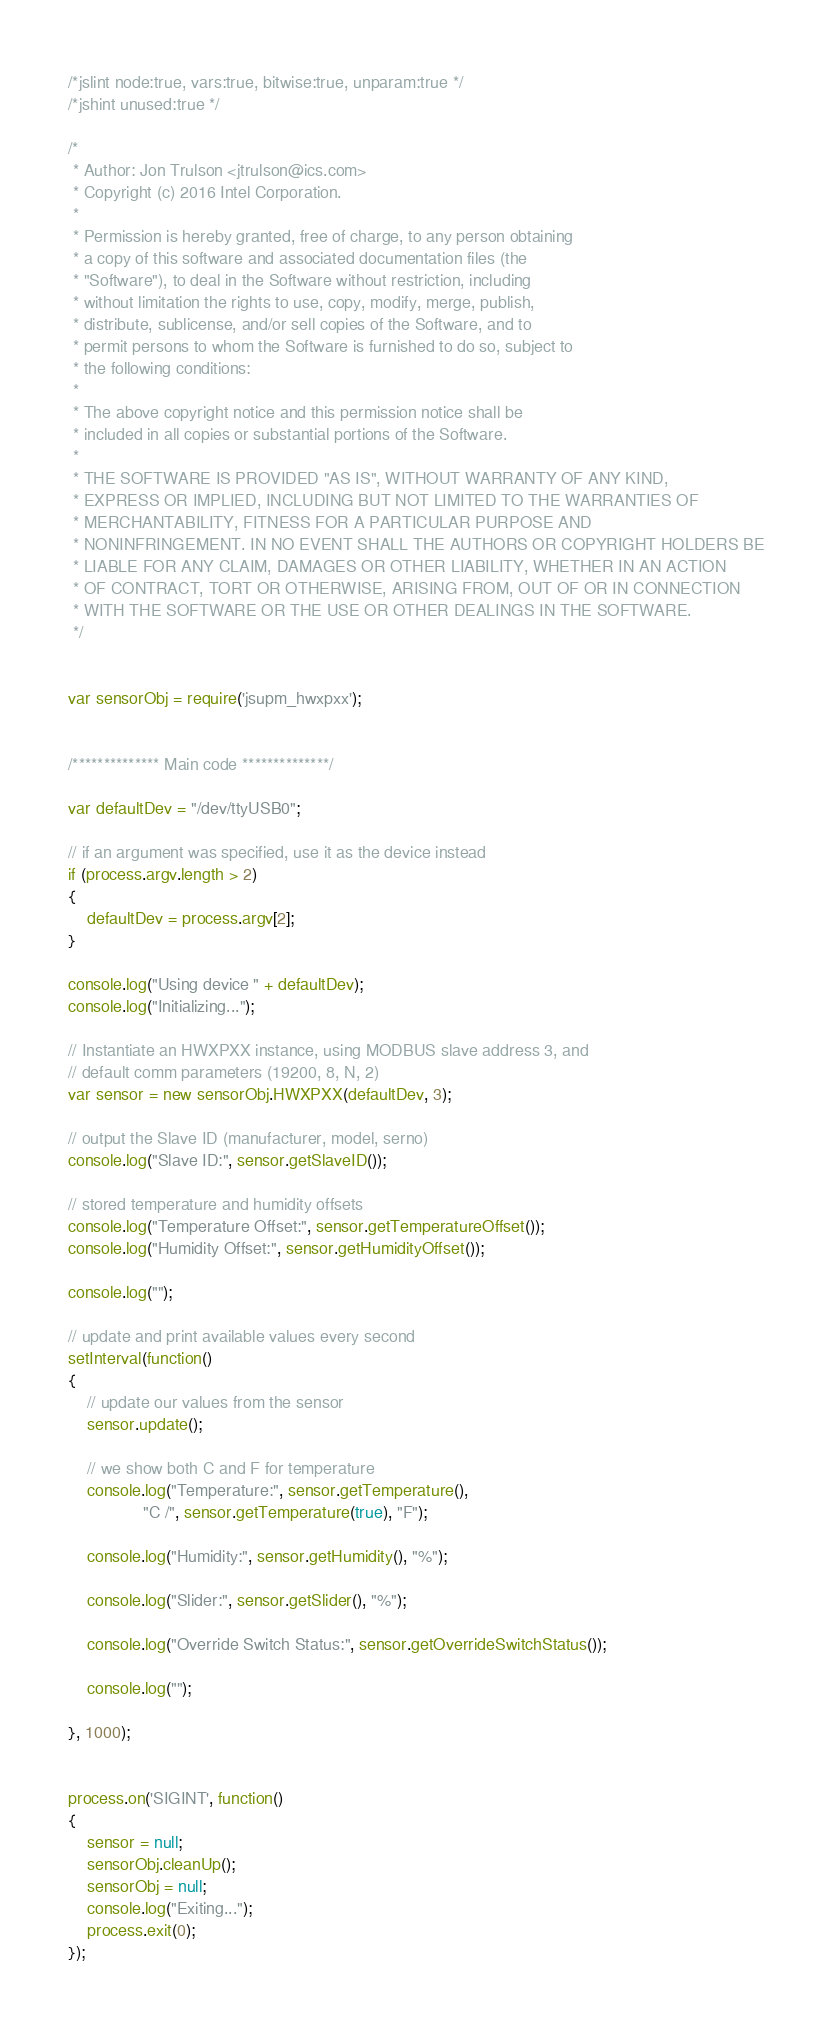<code> <loc_0><loc_0><loc_500><loc_500><_JavaScript_>/*jslint node:true, vars:true, bitwise:true, unparam:true */
/*jshint unused:true */

/*
 * Author: Jon Trulson <jtrulson@ics.com>
 * Copyright (c) 2016 Intel Corporation.
 *
 * Permission is hereby granted, free of charge, to any person obtaining
 * a copy of this software and associated documentation files (the
 * "Software"), to deal in the Software without restriction, including
 * without limitation the rights to use, copy, modify, merge, publish,
 * distribute, sublicense, and/or sell copies of the Software, and to
 * permit persons to whom the Software is furnished to do so, subject to
 * the following conditions:
 *
 * The above copyright notice and this permission notice shall be
 * included in all copies or substantial portions of the Software.
 *
 * THE SOFTWARE IS PROVIDED "AS IS", WITHOUT WARRANTY OF ANY KIND,
 * EXPRESS OR IMPLIED, INCLUDING BUT NOT LIMITED TO THE WARRANTIES OF
 * MERCHANTABILITY, FITNESS FOR A PARTICULAR PURPOSE AND
 * NONINFRINGEMENT. IN NO EVENT SHALL THE AUTHORS OR COPYRIGHT HOLDERS BE
 * LIABLE FOR ANY CLAIM, DAMAGES OR OTHER LIABILITY, WHETHER IN AN ACTION
 * OF CONTRACT, TORT OR OTHERWISE, ARISING FROM, OUT OF OR IN CONNECTION
 * WITH THE SOFTWARE OR THE USE OR OTHER DEALINGS IN THE SOFTWARE.
 */


var sensorObj = require('jsupm_hwxpxx');


/************** Main code **************/

var defaultDev = "/dev/ttyUSB0";

// if an argument was specified, use it as the device instead
if (process.argv.length > 2)
{
    defaultDev = process.argv[2];
}

console.log("Using device " + defaultDev);
console.log("Initializing...");

// Instantiate an HWXPXX instance, using MODBUS slave address 3, and
// default comm parameters (19200, 8, N, 2)
var sensor = new sensorObj.HWXPXX(defaultDev, 3);

// output the Slave ID (manufacturer, model, serno)
console.log("Slave ID:", sensor.getSlaveID());

// stored temperature and humidity offsets
console.log("Temperature Offset:", sensor.getTemperatureOffset());
console.log("Humidity Offset:", sensor.getHumidityOffset());

console.log("");

// update and print available values every second
setInterval(function()
{
    // update our values from the sensor
    sensor.update();

    // we show both C and F for temperature
    console.log("Temperature:", sensor.getTemperature(),
                "C /", sensor.getTemperature(true), "F");

    console.log("Humidity:", sensor.getHumidity(), "%");

    console.log("Slider:", sensor.getSlider(), "%");

    console.log("Override Switch Status:", sensor.getOverrideSwitchStatus());

    console.log("");

}, 1000);


process.on('SIGINT', function()
{
    sensor = null;
    sensorObj.cleanUp();
    sensorObj = null;
    console.log("Exiting...");
    process.exit(0);
});
</code> 